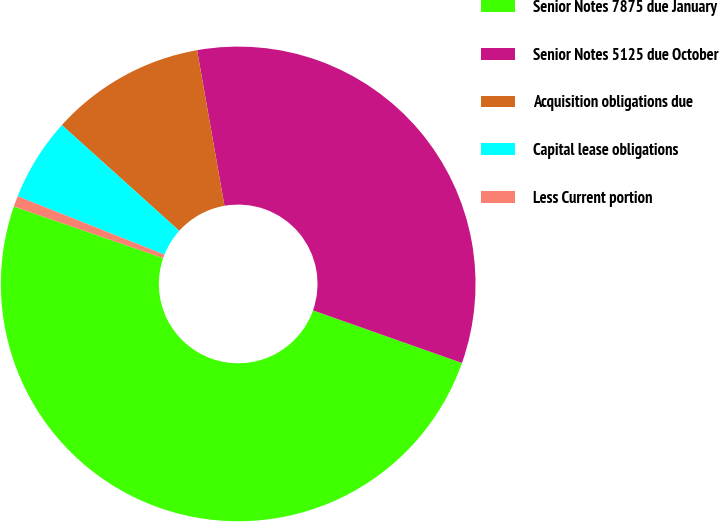Convert chart to OTSL. <chart><loc_0><loc_0><loc_500><loc_500><pie_chart><fcel>Senior Notes 7875 due January<fcel>Senior Notes 5125 due October<fcel>Acquisition obligations due<fcel>Capital lease obligations<fcel>Less Current portion<nl><fcel>49.89%<fcel>33.18%<fcel>10.56%<fcel>5.65%<fcel>0.73%<nl></chart> 